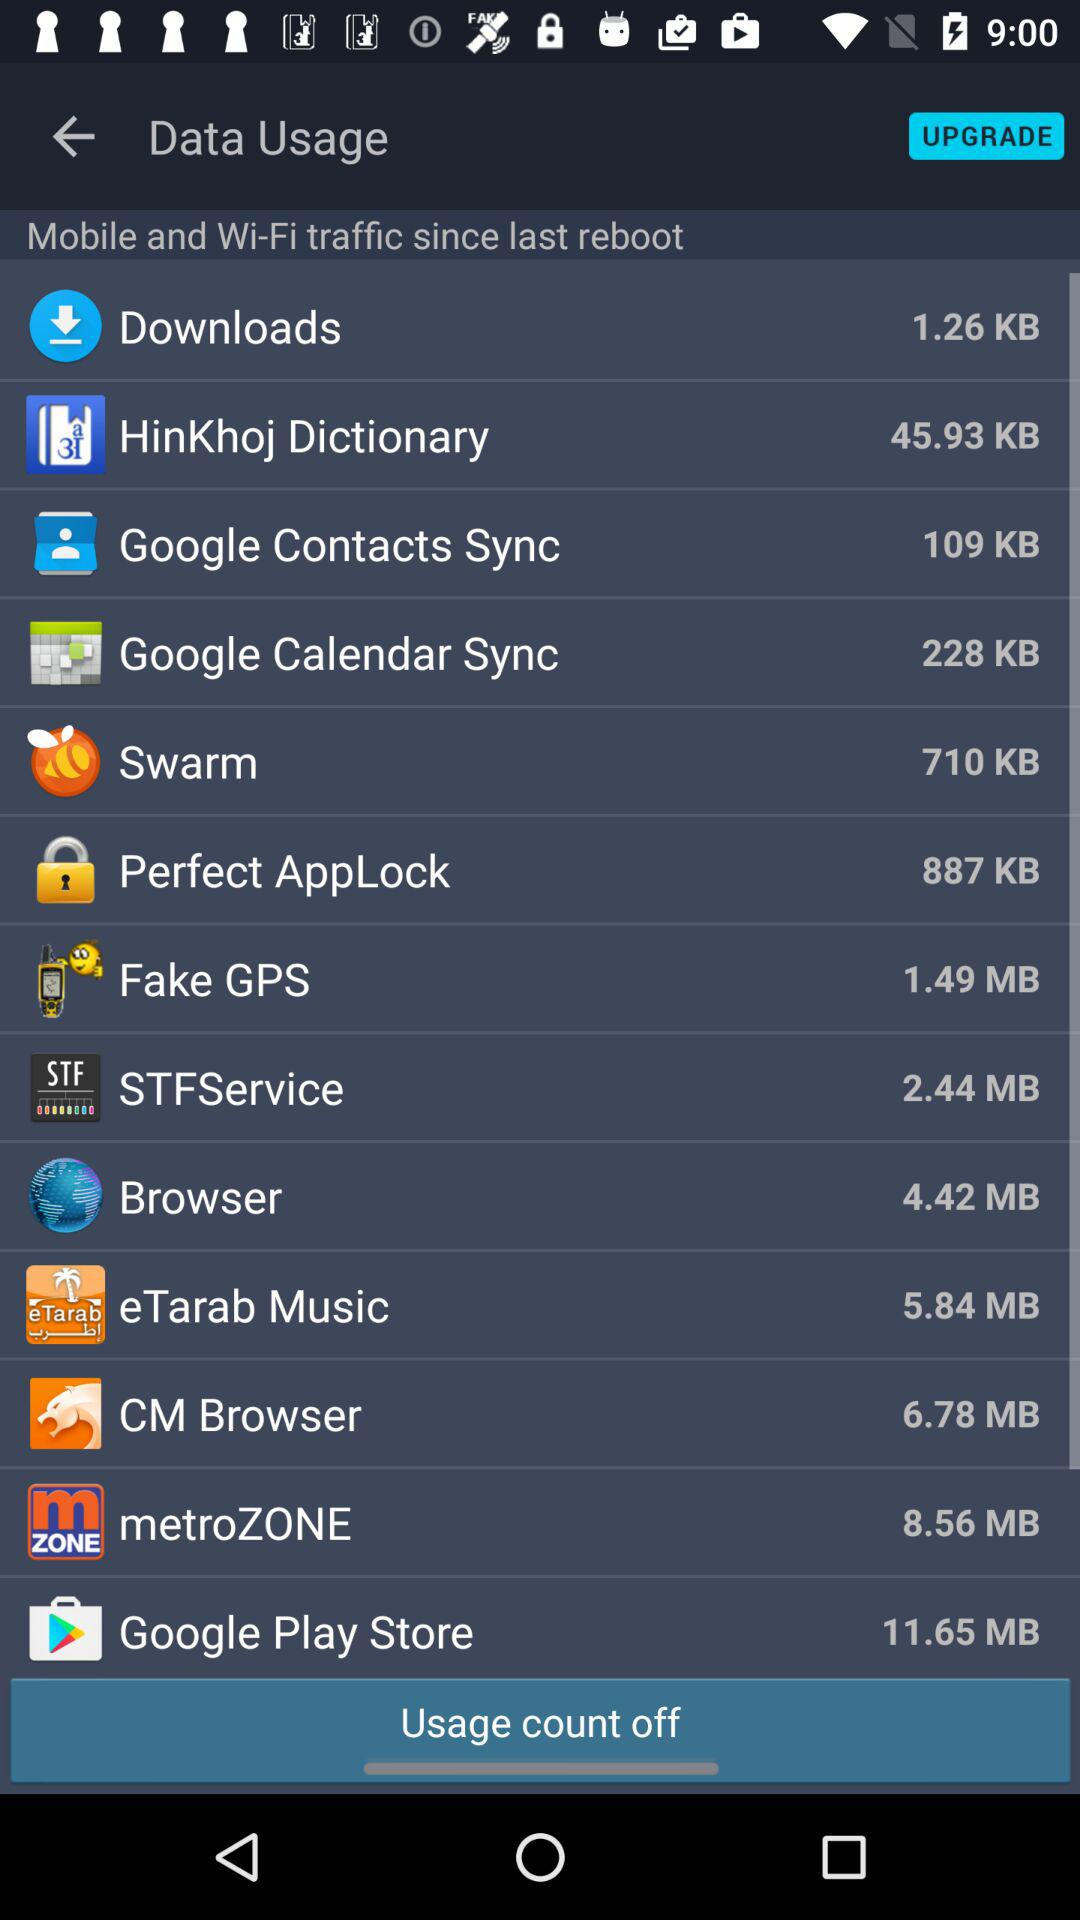How much data is used by "Downloads"? The data used by "Downloads" is 1.26 KB. 